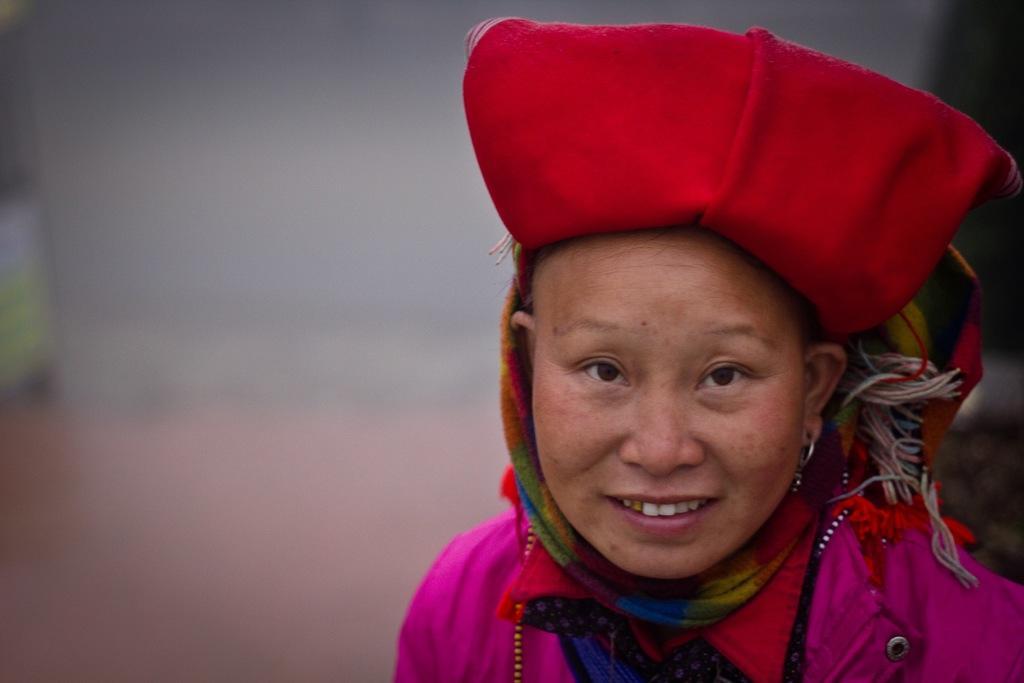Can you describe this image briefly? In this image in front there is a person wearing a smile on her face and the background of the image is blur. 